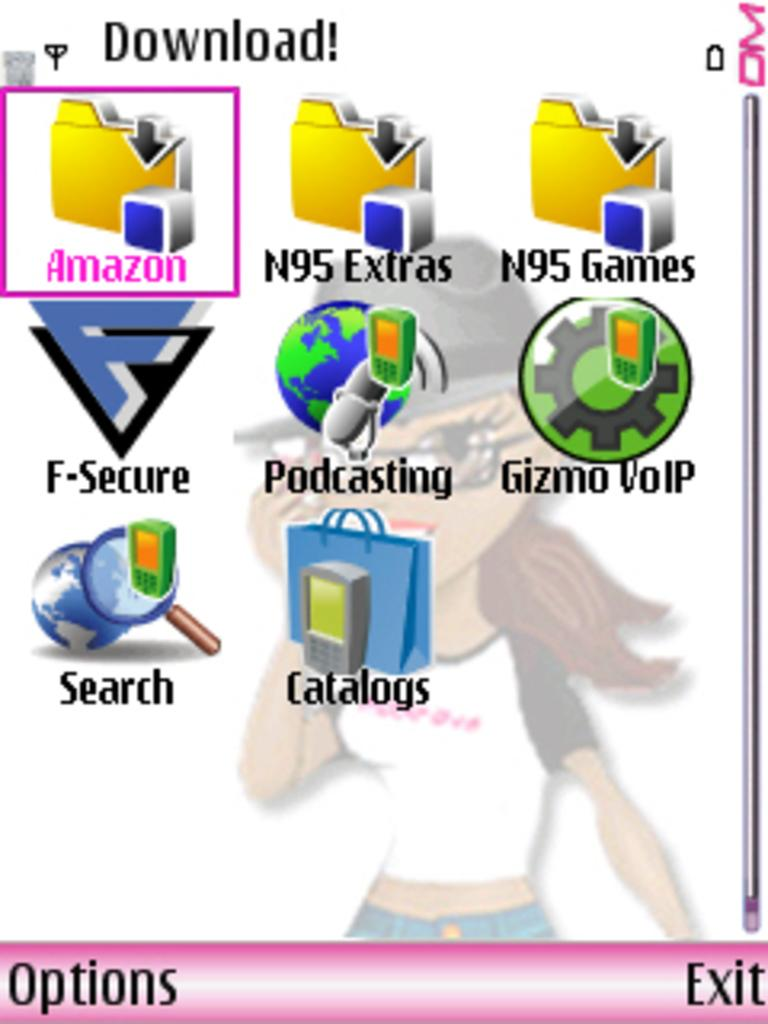What can be found in the image that represents brands or companies? There are logos in the image that represent brands or companies. How do the logos differ from each other in the image? The logos are in different colors in the image. What type of character can be seen in the background of the image? There is a cartoon girl in the background of the image. What color is the cartoon girl in the image? The cartoon girl is in white color. How many babies are sitting on the logos in the image? There are: There are no babies present in the image; it features logos and a cartoon girl. 